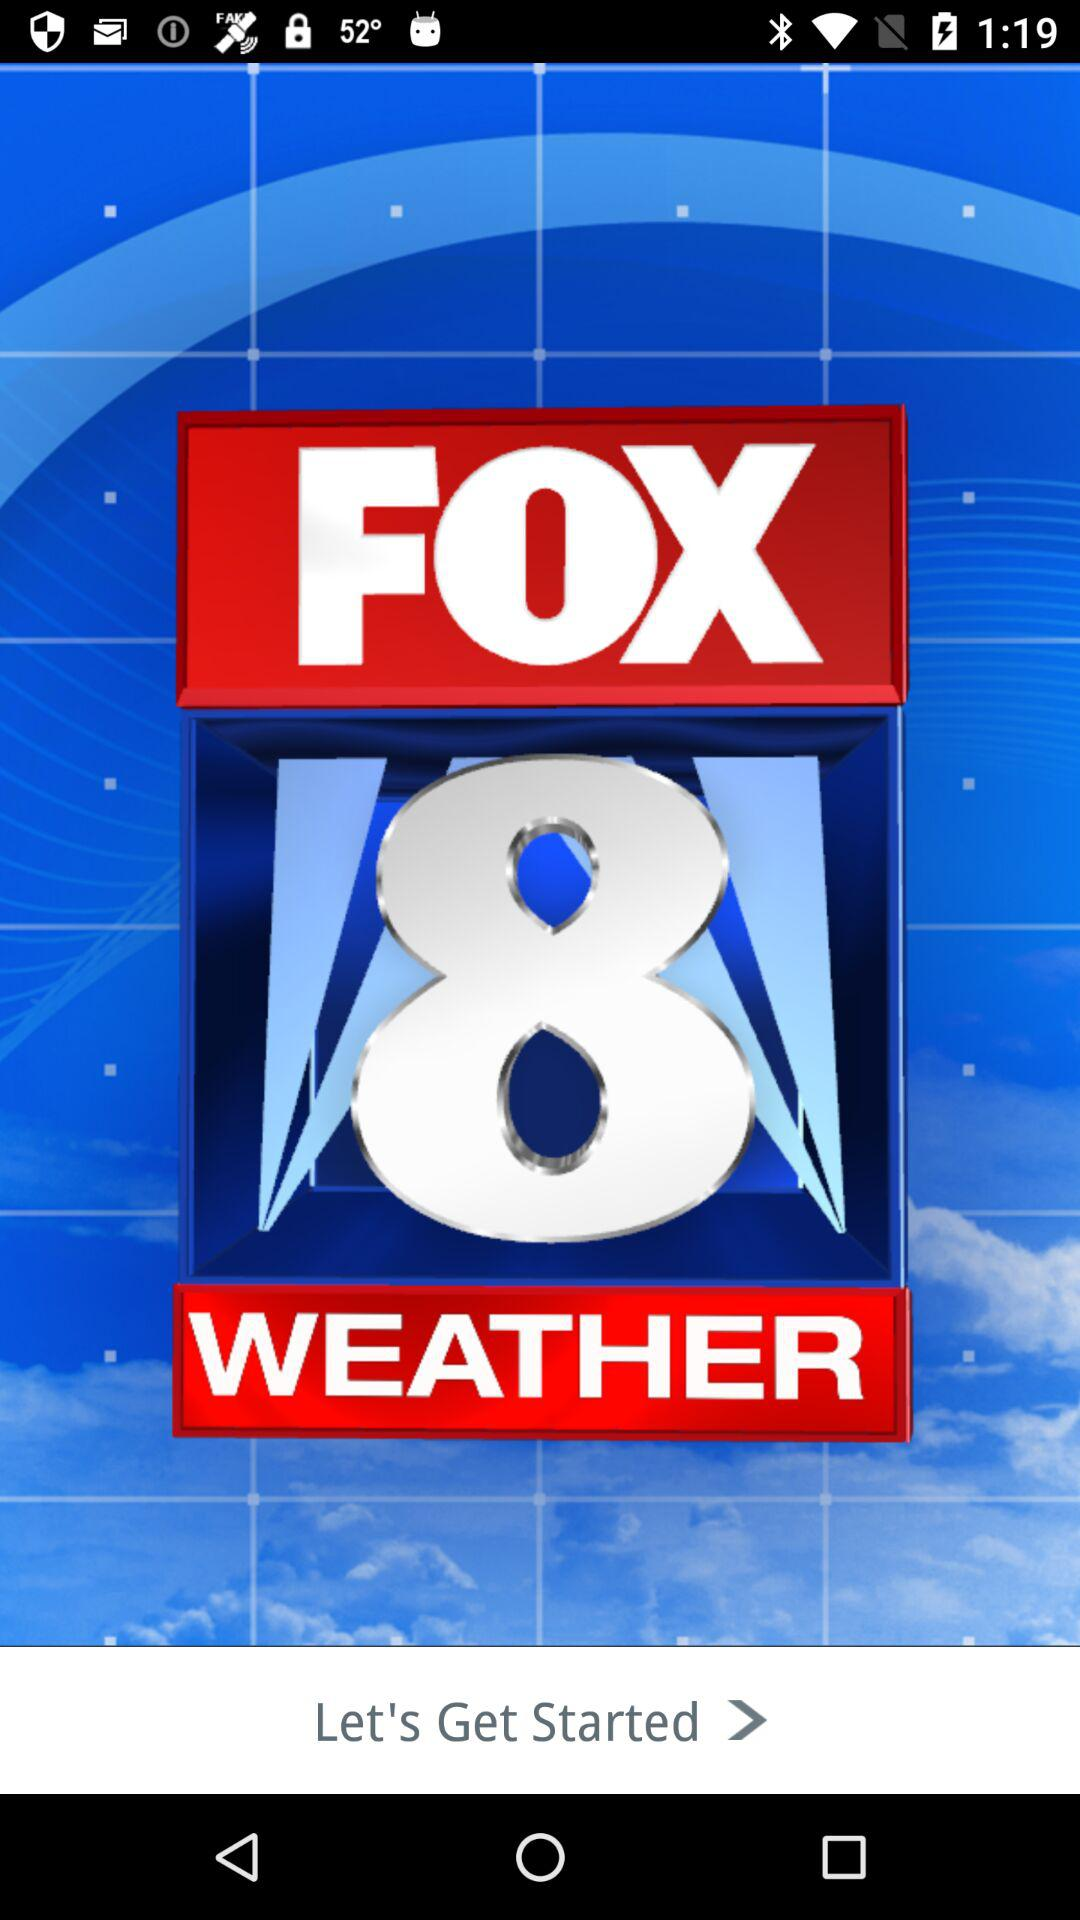What is the name of the application? The name of the application is "FOX 8 WEATHER". 